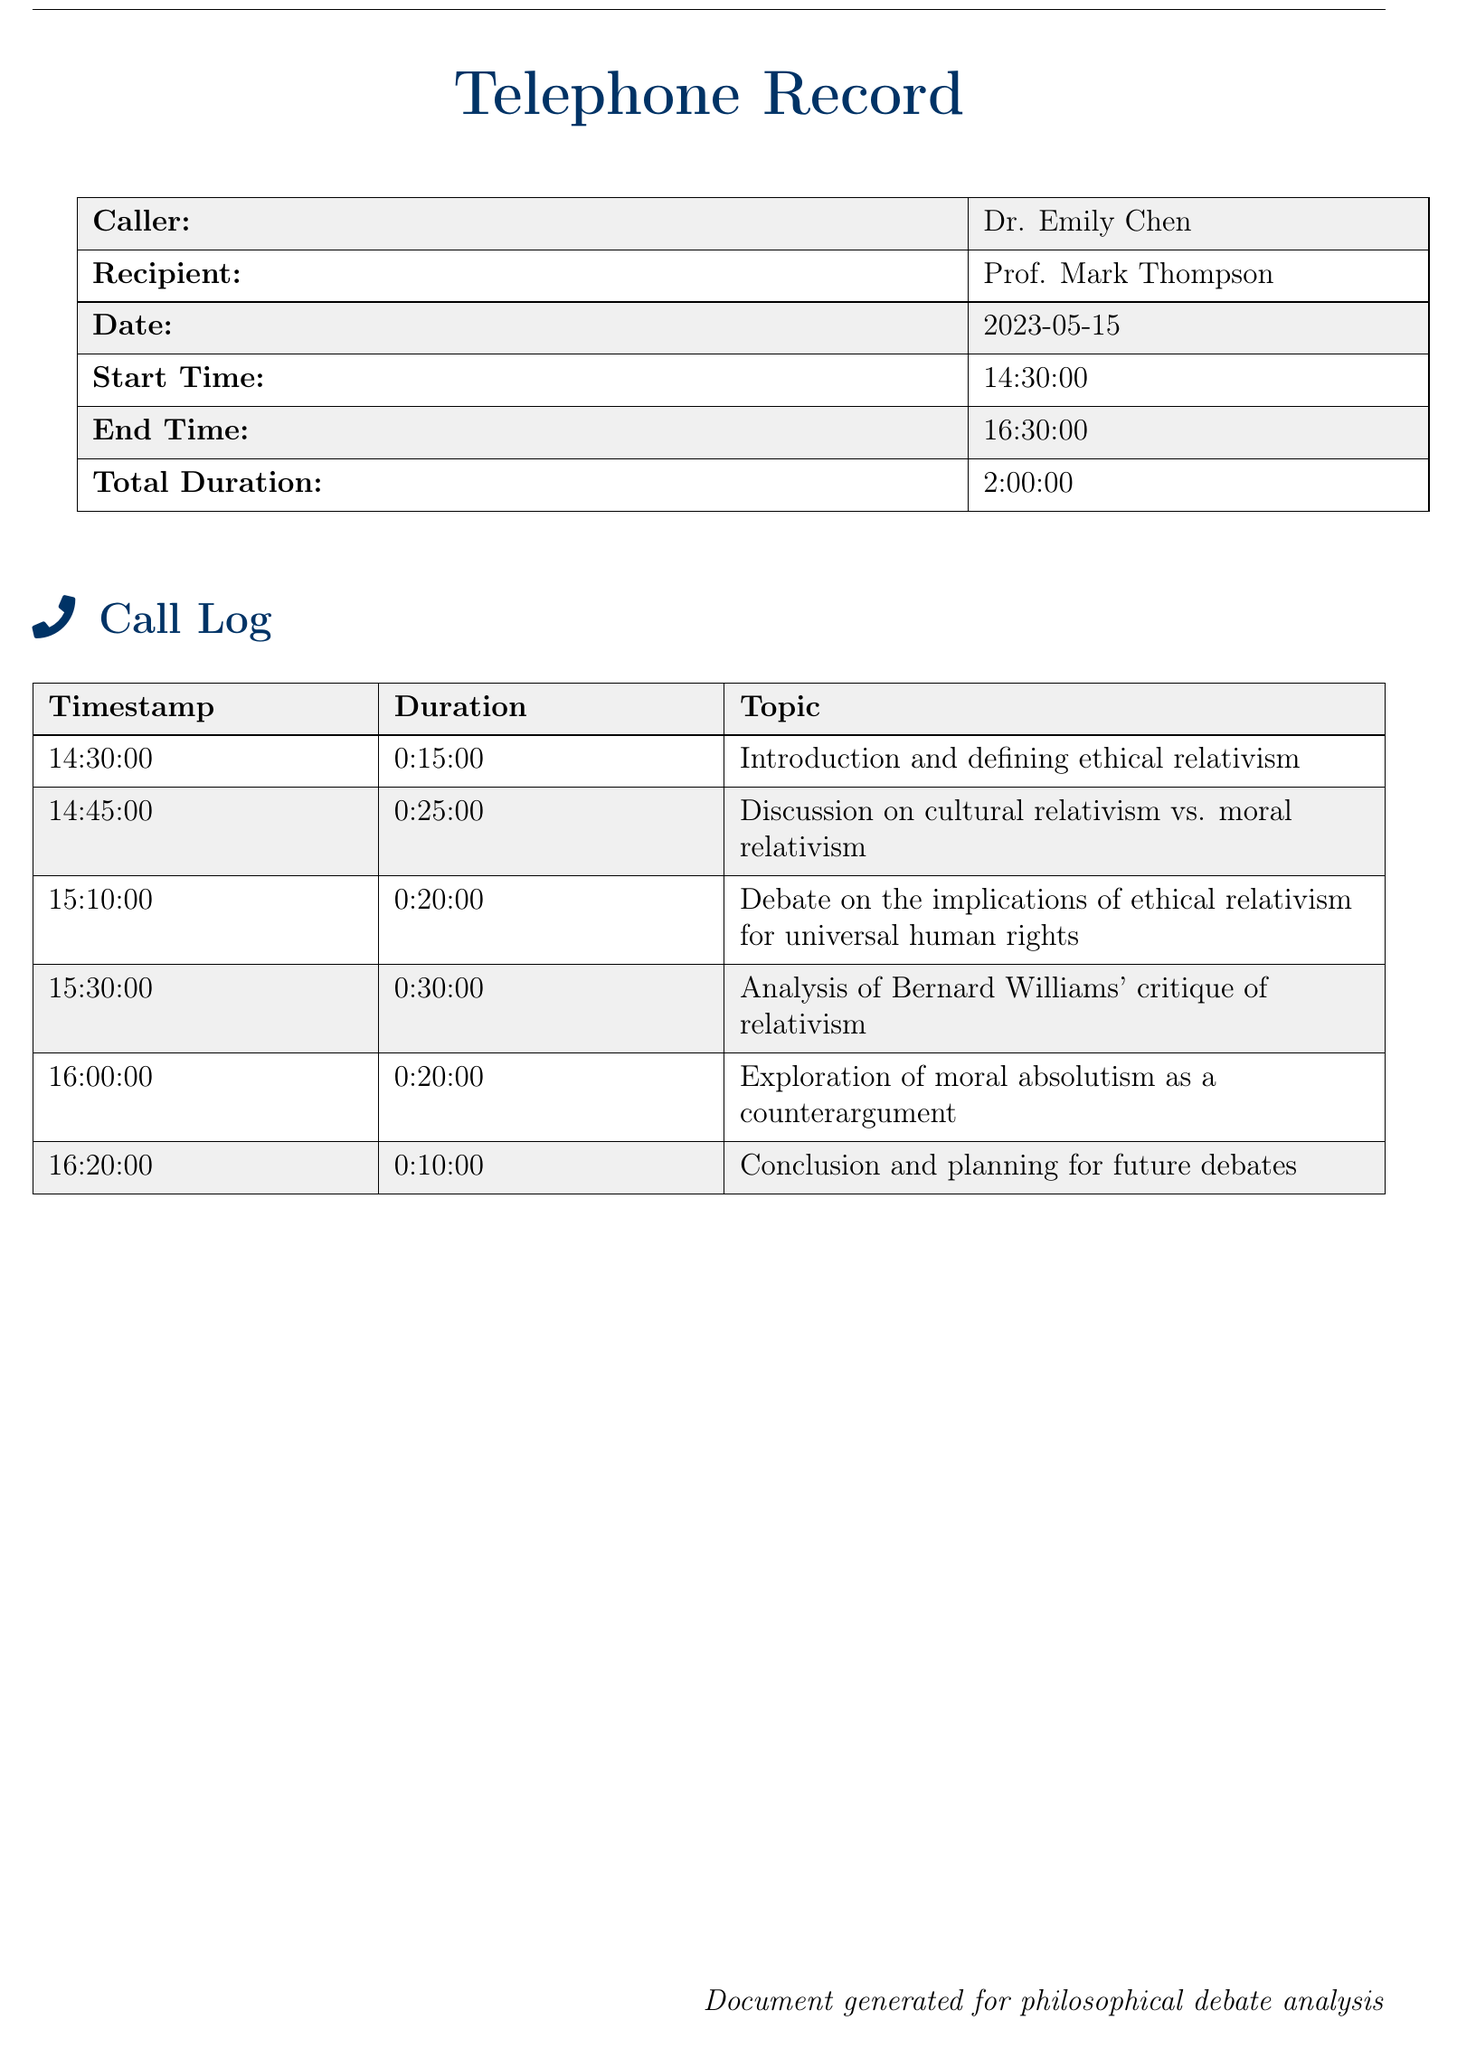What is the date of the call? The date of the call is specified in the document at the top.
Answer: 2023-05-15 Who is the caller? The caller's name is provided in the header section of the document.
Answer: Dr. Emily Chen What was the start time of the call? The start time is listed under the call details at the beginning of the document.
Answer: 14:30:00 What is the total duration of the call? The total duration is calculated and provided in the call details table.
Answer: 2:00:00 How long did the discussion on cultural relativism vs. moral relativism last? The duration for that specific discussion is mentioned in the call log.
Answer: 0:25:00 What topic was discussed at 15:30:00? The topics are outlined in the call log with their respective timestamps.
Answer: Analysis of Bernard Williams' critique of relativism How long was the conclusion and planning for future debates? The duration for the conclusion is listed in the table, detailing the length of time spent.
Answer: 0:10:00 Which topic was explored last in the discussion? The last topic mentioned in the call log encapsulates the final part of the conversation.
Answer: Conclusion and planning for future debates What was the second topic discussed during the call? The second topic was recorded along with its corresponding timestamp.
Answer: Discussion on cultural relativism vs. moral relativism 